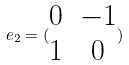<formula> <loc_0><loc_0><loc_500><loc_500>e _ { 2 } = ( \begin{matrix} 0 & - 1 \\ 1 & 0 \end{matrix} )</formula> 